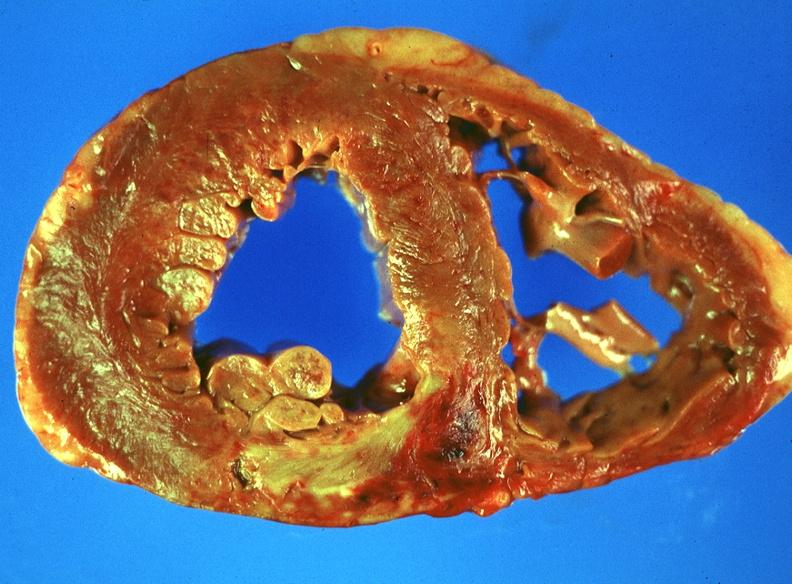does infant body show acute myocardial infarction?
Answer the question using a single word or phrase. No 